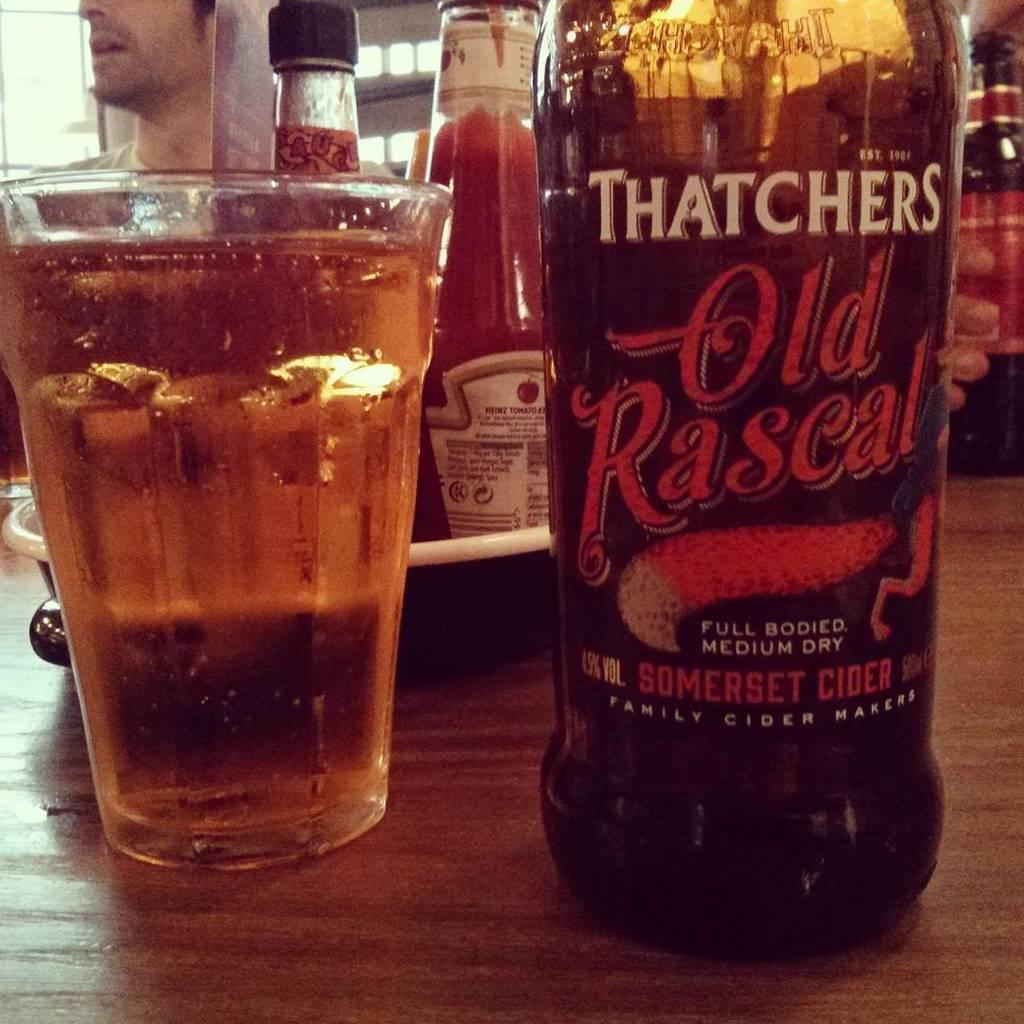<image>
Create a compact narrative representing the image presented. A bottle of Thatchers Somerset Cider sits on a table next to a full glass. 